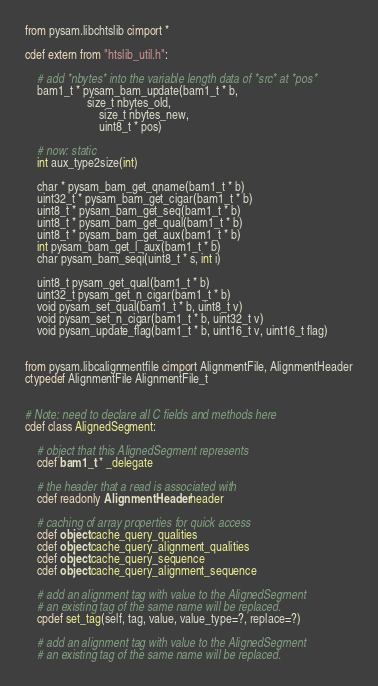<code> <loc_0><loc_0><loc_500><loc_500><_Cython_>from pysam.libchtslib cimport *

cdef extern from "htslib_util.h":

    # add *nbytes* into the variable length data of *src* at *pos*
    bam1_t * pysam_bam_update(bam1_t * b,
           	         size_t nbytes_old,
                         size_t nbytes_new,
                         uint8_t * pos)

    # now: static
    int aux_type2size(int)

    char * pysam_bam_get_qname(bam1_t * b)
    uint32_t * pysam_bam_get_cigar(bam1_t * b)
    uint8_t * pysam_bam_get_seq(bam1_t * b)
    uint8_t * pysam_bam_get_qual(bam1_t * b)
    uint8_t * pysam_bam_get_aux(bam1_t * b)
    int pysam_bam_get_l_aux(bam1_t * b)
    char pysam_bam_seqi(uint8_t * s, int i)

    uint8_t pysam_get_qual(bam1_t * b)
    uint32_t pysam_get_n_cigar(bam1_t * b)
    void pysam_set_qual(bam1_t * b, uint8_t v)
    void pysam_set_n_cigar(bam1_t * b, uint32_t v)
    void pysam_update_flag(bam1_t * b, uint16_t v, uint16_t flag)


from pysam.libcalignmentfile cimport AlignmentFile, AlignmentHeader
ctypedef AlignmentFile AlignmentFile_t


# Note: need to declare all C fields and methods here
cdef class AlignedSegment:

    # object that this AlignedSegment represents
    cdef bam1_t * _delegate

    # the header that a read is associated with
    cdef readonly AlignmentHeader header

    # caching of array properties for quick access
    cdef object cache_query_qualities
    cdef object cache_query_alignment_qualities
    cdef object cache_query_sequence
    cdef object cache_query_alignment_sequence

    # add an alignment tag with value to the AlignedSegment
    # an existing tag of the same name will be replaced.
    cpdef set_tag(self, tag, value, value_type=?, replace=?)

    # add an alignment tag with value to the AlignedSegment
    # an existing tag of the same name will be replaced.</code> 